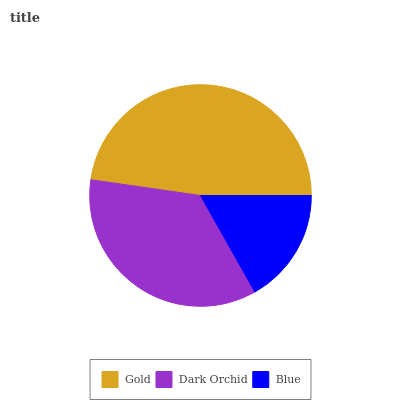Is Blue the minimum?
Answer yes or no. Yes. Is Gold the maximum?
Answer yes or no. Yes. Is Dark Orchid the minimum?
Answer yes or no. No. Is Dark Orchid the maximum?
Answer yes or no. No. Is Gold greater than Dark Orchid?
Answer yes or no. Yes. Is Dark Orchid less than Gold?
Answer yes or no. Yes. Is Dark Orchid greater than Gold?
Answer yes or no. No. Is Gold less than Dark Orchid?
Answer yes or no. No. Is Dark Orchid the high median?
Answer yes or no. Yes. Is Dark Orchid the low median?
Answer yes or no. Yes. Is Blue the high median?
Answer yes or no. No. Is Blue the low median?
Answer yes or no. No. 